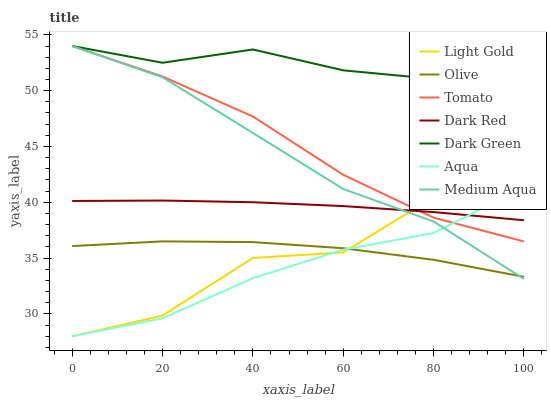Does Aqua have the minimum area under the curve?
Answer yes or no. Yes. Does Dark Green have the maximum area under the curve?
Answer yes or no. Yes. Does Dark Red have the minimum area under the curve?
Answer yes or no. No. Does Dark Red have the maximum area under the curve?
Answer yes or no. No. Is Dark Red the smoothest?
Answer yes or no. Yes. Is Light Gold the roughest?
Answer yes or no. Yes. Is Aqua the smoothest?
Answer yes or no. No. Is Aqua the roughest?
Answer yes or no. No. Does Aqua have the lowest value?
Answer yes or no. Yes. Does Dark Red have the lowest value?
Answer yes or no. No. Does Dark Green have the highest value?
Answer yes or no. Yes. Does Dark Red have the highest value?
Answer yes or no. No. Is Light Gold less than Dark Green?
Answer yes or no. Yes. Is Dark Green greater than Dark Red?
Answer yes or no. Yes. Does Medium Aqua intersect Dark Red?
Answer yes or no. Yes. Is Medium Aqua less than Dark Red?
Answer yes or no. No. Is Medium Aqua greater than Dark Red?
Answer yes or no. No. Does Light Gold intersect Dark Green?
Answer yes or no. No. 